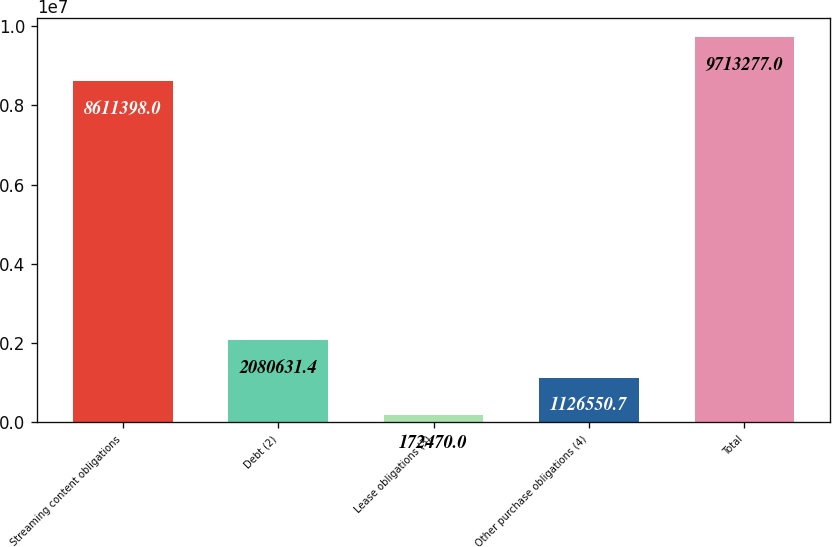Convert chart. <chart><loc_0><loc_0><loc_500><loc_500><bar_chart><fcel>Streaming content obligations<fcel>Debt (2)<fcel>Lease obligations (3)<fcel>Other purchase obligations (4)<fcel>Total<nl><fcel>8.6114e+06<fcel>2.08063e+06<fcel>172470<fcel>1.12655e+06<fcel>9.71328e+06<nl></chart> 